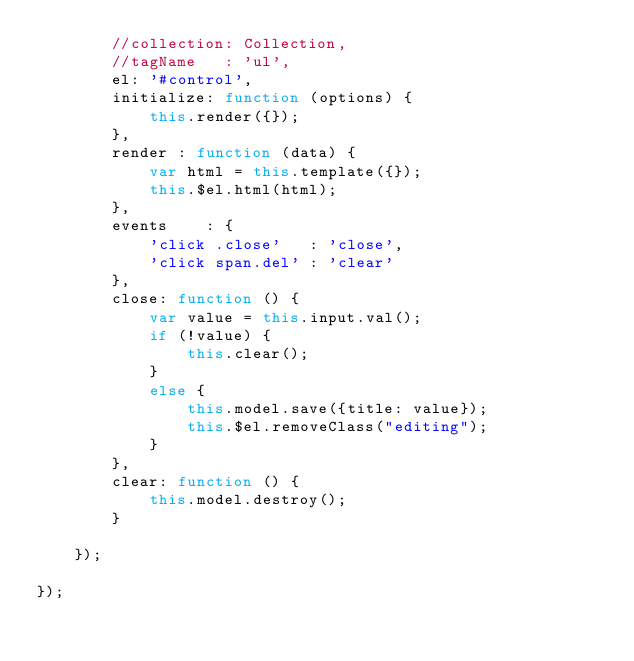Convert code to text. <code><loc_0><loc_0><loc_500><loc_500><_JavaScript_>        //collection: Collection,
        //tagName   : 'ul',
        el: '#control',
        initialize: function (options) {
            this.render({});
        },
        render : function (data) {
            var html = this.template({});
            this.$el.html(html);
        },
        events    : {
            'click .close'   : 'close',
            'click span.del' : 'clear'
        },
        close: function () {
            var value = this.input.val();
            if (!value) {
                this.clear();
            }
            else {
                this.model.save({title: value});
                this.$el.removeClass("editing");
            }
        },
        clear: function () {
            this.model.destroy();
        }

    });

});
</code> 